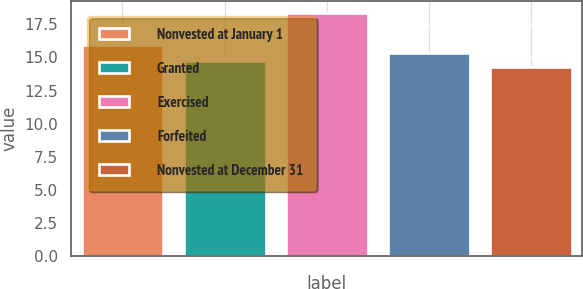Convert chart. <chart><loc_0><loc_0><loc_500><loc_500><bar_chart><fcel>Nonvested at January 1<fcel>Granted<fcel>Exercised<fcel>Forfeited<fcel>Nonvested at December 31<nl><fcel>15.95<fcel>14.72<fcel>18.37<fcel>15.35<fcel>14.32<nl></chart> 